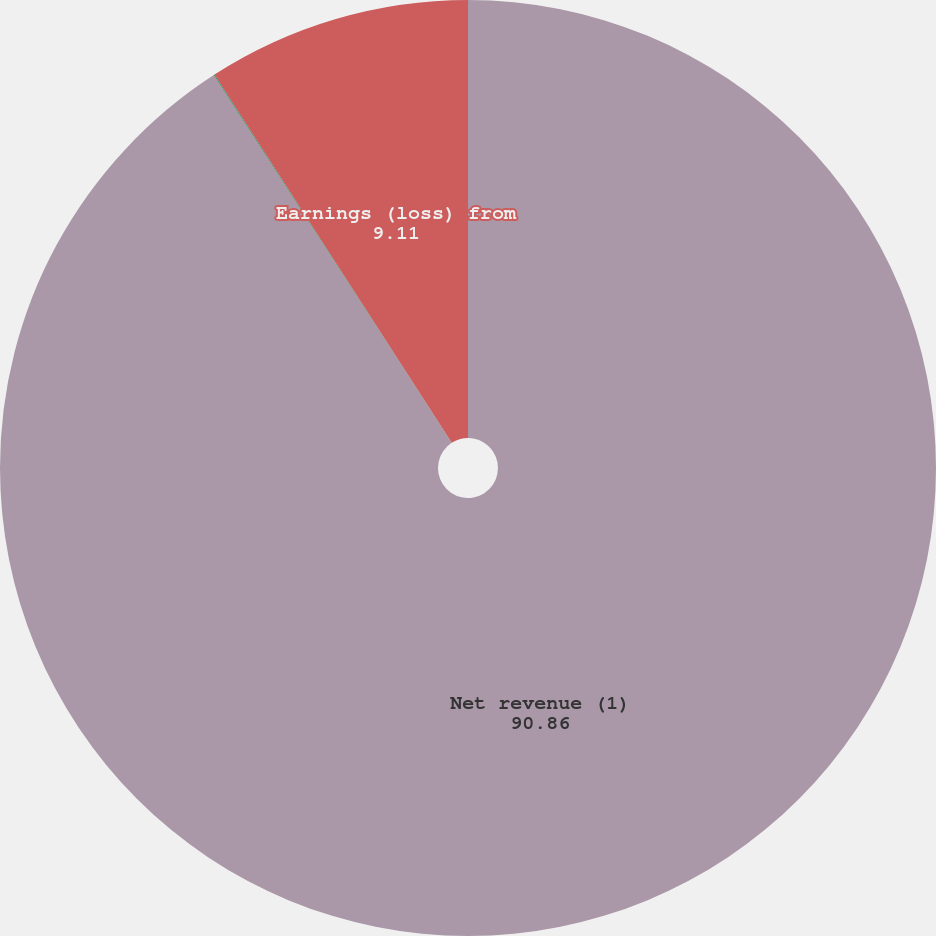<chart> <loc_0><loc_0><loc_500><loc_500><pie_chart><fcel>Net revenue (1)<fcel>Year-over-year change<fcel>Earnings (loss) from<nl><fcel>90.86%<fcel>0.03%<fcel>9.11%<nl></chart> 